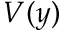Convert formula to latex. <formula><loc_0><loc_0><loc_500><loc_500>V ( y )</formula> 